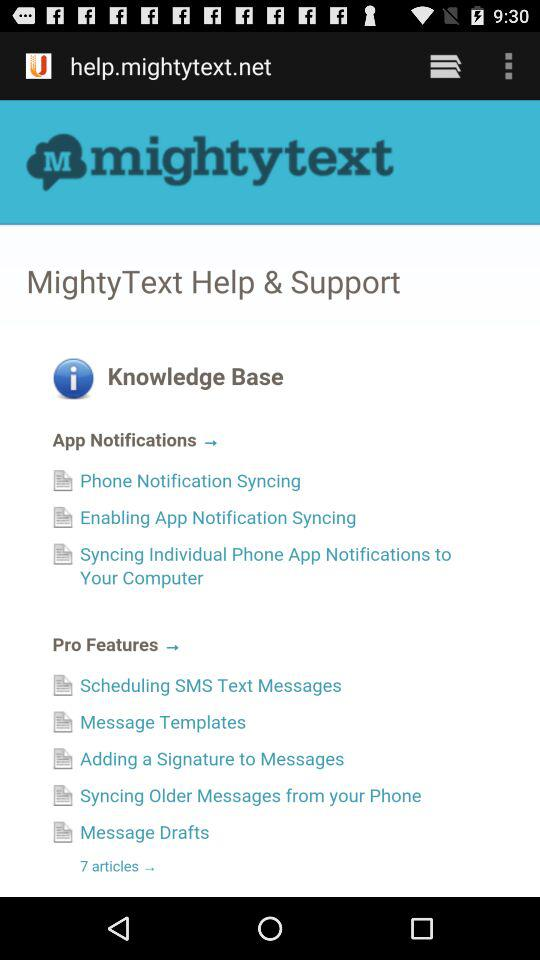How many articles are there in the App Notifications section?
Answer the question using a single word or phrase. 3 